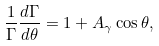Convert formula to latex. <formula><loc_0><loc_0><loc_500><loc_500>\frac { 1 } { \Gamma } \frac { d \Gamma } { d \theta } = 1 + A _ { \gamma } \cos \theta ,</formula> 